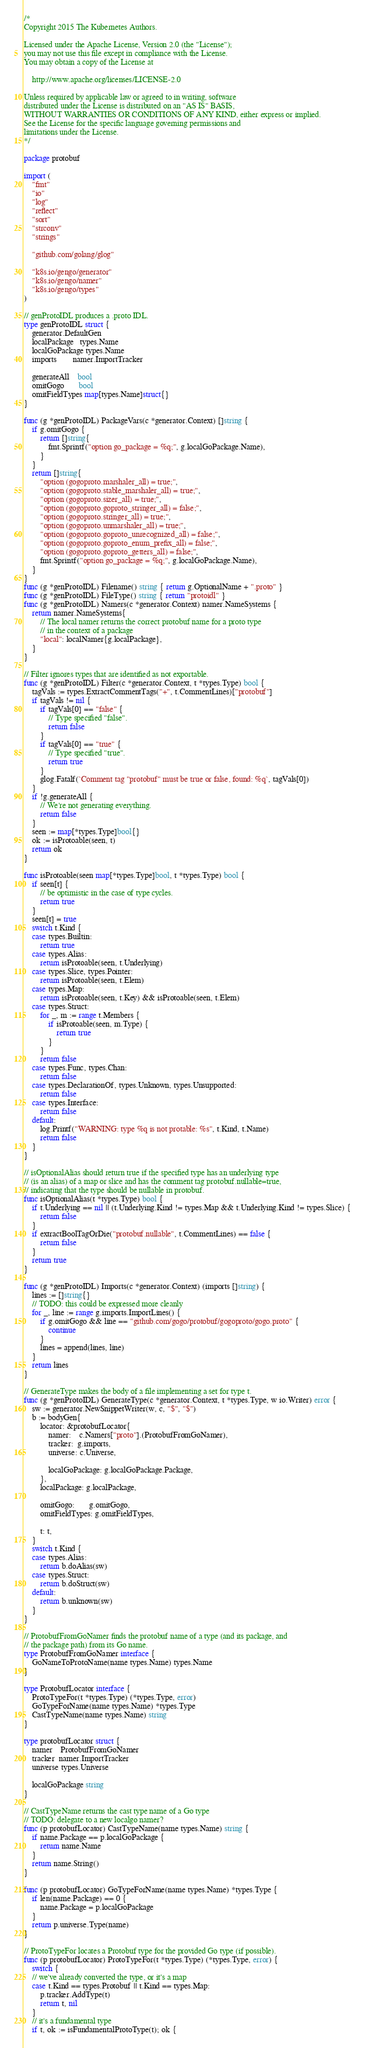<code> <loc_0><loc_0><loc_500><loc_500><_Go_>/*
Copyright 2015 The Kubernetes Authors.

Licensed under the Apache License, Version 2.0 (the "License");
you may not use this file except in compliance with the License.
You may obtain a copy of the License at

    http://www.apache.org/licenses/LICENSE-2.0

Unless required by applicable law or agreed to in writing, software
distributed under the License is distributed on an "AS IS" BASIS,
WITHOUT WARRANTIES OR CONDITIONS OF ANY KIND, either express or implied.
See the License for the specific language governing permissions and
limitations under the License.
*/

package protobuf

import (
	"fmt"
	"io"
	"log"
	"reflect"
	"sort"
	"strconv"
	"strings"

	"github.com/golang/glog"

	"k8s.io/gengo/generator"
	"k8s.io/gengo/namer"
	"k8s.io/gengo/types"
)

// genProtoIDL produces a .proto IDL.
type genProtoIDL struct {
	generator.DefaultGen
	localPackage   types.Name
	localGoPackage types.Name
	imports        namer.ImportTracker

	generateAll    bool
	omitGogo       bool
	omitFieldTypes map[types.Name]struct{}
}

func (g *genProtoIDL) PackageVars(c *generator.Context) []string {
	if g.omitGogo {
		return []string{
			fmt.Sprintf("option go_package = %q;", g.localGoPackage.Name),
		}
	}
	return []string{
		"option (gogoproto.marshaler_all) = true;",
		"option (gogoproto.stable_marshaler_all) = true;",
		"option (gogoproto.sizer_all) = true;",
		"option (gogoproto.goproto_stringer_all) = false;",
		"option (gogoproto.stringer_all) = true;",
		"option (gogoproto.unmarshaler_all) = true;",
		"option (gogoproto.goproto_unrecognized_all) = false;",
		"option (gogoproto.goproto_enum_prefix_all) = false;",
		"option (gogoproto.goproto_getters_all) = false;",
		fmt.Sprintf("option go_package = %q;", g.localGoPackage.Name),
	}
}
func (g *genProtoIDL) Filename() string { return g.OptionalName + ".proto" }
func (g *genProtoIDL) FileType() string { return "protoidl" }
func (g *genProtoIDL) Namers(c *generator.Context) namer.NameSystems {
	return namer.NameSystems{
		// The local namer returns the correct protobuf name for a proto type
		// in the context of a package
		"local": localNamer{g.localPackage},
	}
}

// Filter ignores types that are identified as not exportable.
func (g *genProtoIDL) Filter(c *generator.Context, t *types.Type) bool {
	tagVals := types.ExtractCommentTags("+", t.CommentLines)["protobuf"]
	if tagVals != nil {
		if tagVals[0] == "false" {
			// Type specified "false".
			return false
		}
		if tagVals[0] == "true" {
			// Type specified "true".
			return true
		}
		glog.Fatalf(`Comment tag "protobuf" must be true or false, found: %q`, tagVals[0])
	}
	if !g.generateAll {
		// We're not generating everything.
		return false
	}
	seen := map[*types.Type]bool{}
	ok := isProtoable(seen, t)
	return ok
}

func isProtoable(seen map[*types.Type]bool, t *types.Type) bool {
	if seen[t] {
		// be optimistic in the case of type cycles.
		return true
	}
	seen[t] = true
	switch t.Kind {
	case types.Builtin:
		return true
	case types.Alias:
		return isProtoable(seen, t.Underlying)
	case types.Slice, types.Pointer:
		return isProtoable(seen, t.Elem)
	case types.Map:
		return isProtoable(seen, t.Key) && isProtoable(seen, t.Elem)
	case types.Struct:
		for _, m := range t.Members {
			if isProtoable(seen, m.Type) {
				return true
			}
		}
		return false
	case types.Func, types.Chan:
		return false
	case types.DeclarationOf, types.Unknown, types.Unsupported:
		return false
	case types.Interface:
		return false
	default:
		log.Printf("WARNING: type %q is not protable: %s", t.Kind, t.Name)
		return false
	}
}

// isOptionalAlias should return true if the specified type has an underlying type
// (is an alias) of a map or slice and has the comment tag protobuf.nullable=true,
// indicating that the type should be nullable in protobuf.
func isOptionalAlias(t *types.Type) bool {
	if t.Underlying == nil || (t.Underlying.Kind != types.Map && t.Underlying.Kind != types.Slice) {
		return false
	}
	if extractBoolTagOrDie("protobuf.nullable", t.CommentLines) == false {
		return false
	}
	return true
}

func (g *genProtoIDL) Imports(c *generator.Context) (imports []string) {
	lines := []string{}
	// TODO: this could be expressed more cleanly
	for _, line := range g.imports.ImportLines() {
		if g.omitGogo && line == "github.com/gogo/protobuf/gogoproto/gogo.proto" {
			continue
		}
		lines = append(lines, line)
	}
	return lines
}

// GenerateType makes the body of a file implementing a set for type t.
func (g *genProtoIDL) GenerateType(c *generator.Context, t *types.Type, w io.Writer) error {
	sw := generator.NewSnippetWriter(w, c, "$", "$")
	b := bodyGen{
		locator: &protobufLocator{
			namer:    c.Namers["proto"].(ProtobufFromGoNamer),
			tracker:  g.imports,
			universe: c.Universe,

			localGoPackage: g.localGoPackage.Package,
		},
		localPackage: g.localPackage,

		omitGogo:       g.omitGogo,
		omitFieldTypes: g.omitFieldTypes,

		t: t,
	}
	switch t.Kind {
	case types.Alias:
		return b.doAlias(sw)
	case types.Struct:
		return b.doStruct(sw)
	default:
		return b.unknown(sw)
	}
}

// ProtobufFromGoNamer finds the protobuf name of a type (and its package, and
// the package path) from its Go name.
type ProtobufFromGoNamer interface {
	GoNameToProtoName(name types.Name) types.Name
}

type ProtobufLocator interface {
	ProtoTypeFor(t *types.Type) (*types.Type, error)
	GoTypeForName(name types.Name) *types.Type
	CastTypeName(name types.Name) string
}

type protobufLocator struct {
	namer    ProtobufFromGoNamer
	tracker  namer.ImportTracker
	universe types.Universe

	localGoPackage string
}

// CastTypeName returns the cast type name of a Go type
// TODO: delegate to a new localgo namer?
func (p protobufLocator) CastTypeName(name types.Name) string {
	if name.Package == p.localGoPackage {
		return name.Name
	}
	return name.String()
}

func (p protobufLocator) GoTypeForName(name types.Name) *types.Type {
	if len(name.Package) == 0 {
		name.Package = p.localGoPackage
	}
	return p.universe.Type(name)
}

// ProtoTypeFor locates a Protobuf type for the provided Go type (if possible).
func (p protobufLocator) ProtoTypeFor(t *types.Type) (*types.Type, error) {
	switch {
	// we've already converted the type, or it's a map
	case t.Kind == types.Protobuf || t.Kind == types.Map:
		p.tracker.AddType(t)
		return t, nil
	}
	// it's a fundamental type
	if t, ok := isFundamentalProtoType(t); ok {</code> 